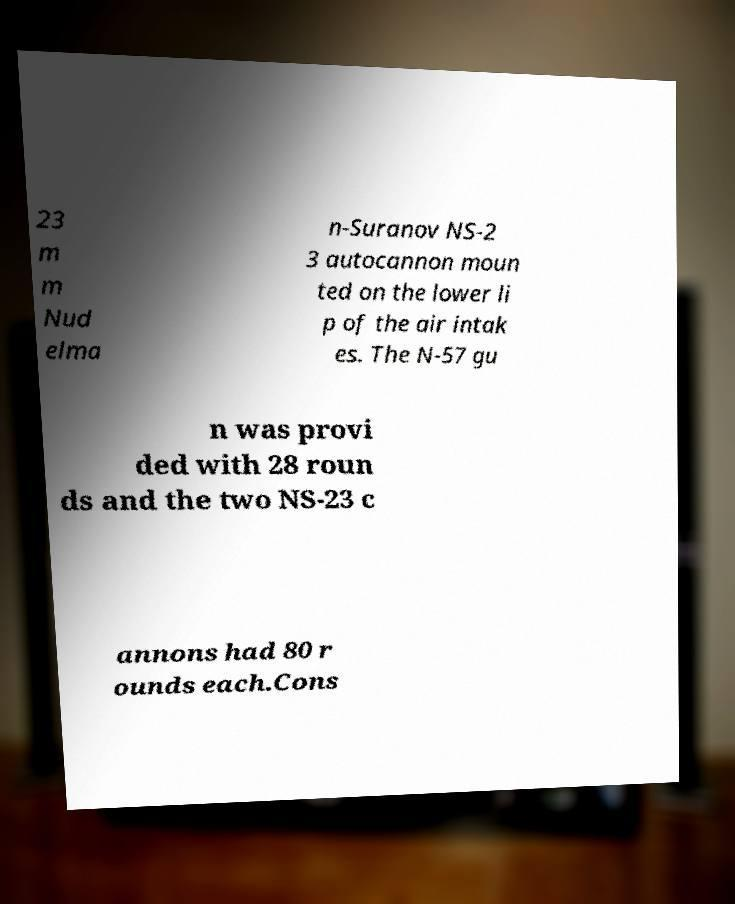I need the written content from this picture converted into text. Can you do that? 23 m m Nud elma n-Suranov NS-2 3 autocannon moun ted on the lower li p of the air intak es. The N-57 gu n was provi ded with 28 roun ds and the two NS-23 c annons had 80 r ounds each.Cons 